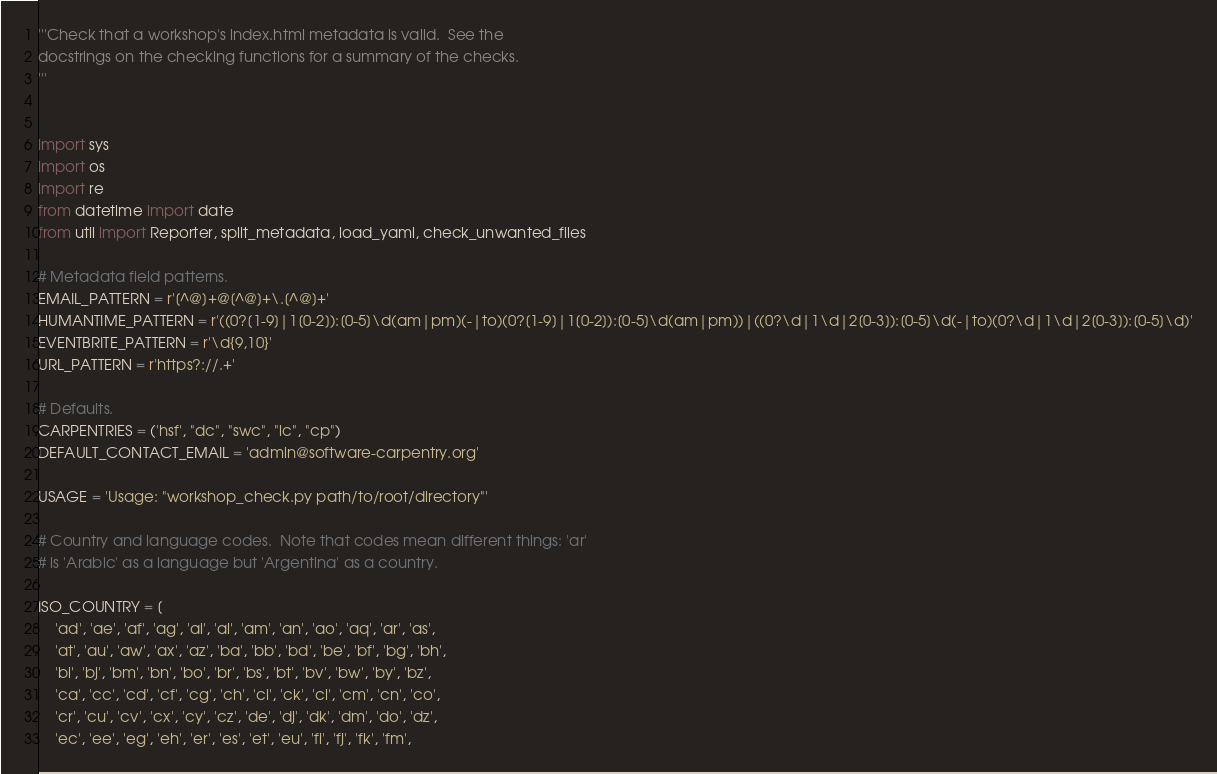<code> <loc_0><loc_0><loc_500><loc_500><_Python_>'''Check that a workshop's index.html metadata is valid.  See the
docstrings on the checking functions for a summary of the checks.
'''


import sys
import os
import re
from datetime import date
from util import Reporter, split_metadata, load_yaml, check_unwanted_files

# Metadata field patterns.
EMAIL_PATTERN = r'[^@]+@[^@]+\.[^@]+'
HUMANTIME_PATTERN = r'((0?[1-9]|1[0-2]):[0-5]\d(am|pm)(-|to)(0?[1-9]|1[0-2]):[0-5]\d(am|pm))|((0?\d|1\d|2[0-3]):[0-5]\d(-|to)(0?\d|1\d|2[0-3]):[0-5]\d)'
EVENTBRITE_PATTERN = r'\d{9,10}'
URL_PATTERN = r'https?://.+'

# Defaults.
CARPENTRIES = ('hsf', "dc", "swc", "lc", "cp")
DEFAULT_CONTACT_EMAIL = 'admin@software-carpentry.org'

USAGE = 'Usage: "workshop_check.py path/to/root/directory"'

# Country and language codes.  Note that codes mean different things: 'ar'
# is 'Arabic' as a language but 'Argentina' as a country.

ISO_COUNTRY = [
    'ad', 'ae', 'af', 'ag', 'ai', 'al', 'am', 'an', 'ao', 'aq', 'ar', 'as',
    'at', 'au', 'aw', 'ax', 'az', 'ba', 'bb', 'bd', 'be', 'bf', 'bg', 'bh',
    'bi', 'bj', 'bm', 'bn', 'bo', 'br', 'bs', 'bt', 'bv', 'bw', 'by', 'bz',
    'ca', 'cc', 'cd', 'cf', 'cg', 'ch', 'ci', 'ck', 'cl', 'cm', 'cn', 'co',
    'cr', 'cu', 'cv', 'cx', 'cy', 'cz', 'de', 'dj', 'dk', 'dm', 'do', 'dz',
    'ec', 'ee', 'eg', 'eh', 'er', 'es', 'et', 'eu', 'fi', 'fj', 'fk', 'fm',</code> 